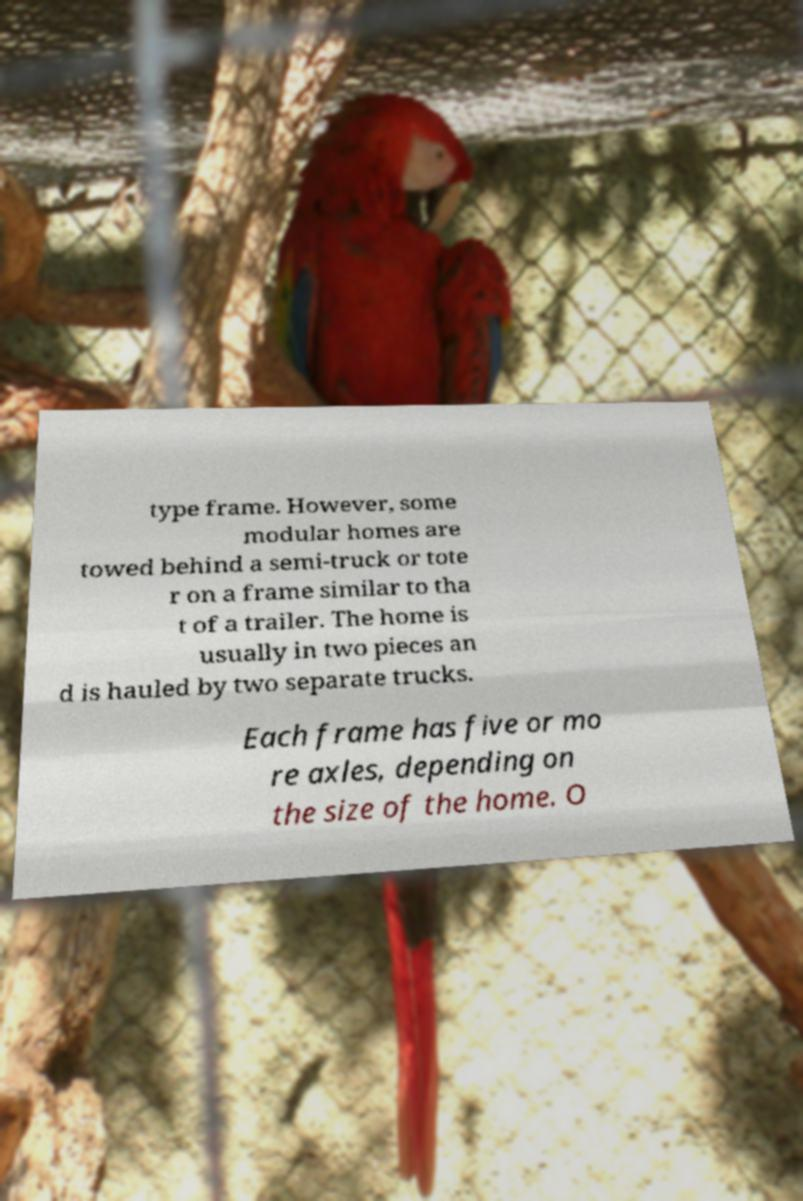Please read and relay the text visible in this image. What does it say? type frame. However, some modular homes are towed behind a semi-truck or tote r on a frame similar to tha t of a trailer. The home is usually in two pieces an d is hauled by two separate trucks. Each frame has five or mo re axles, depending on the size of the home. O 